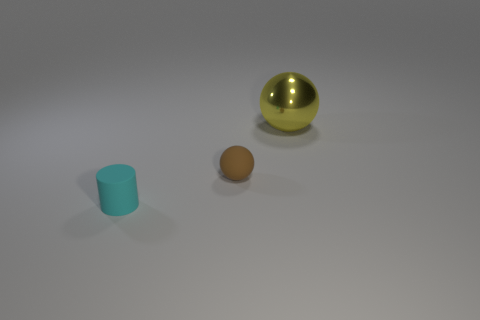Add 1 spheres. How many objects exist? 4 Subtract 1 yellow spheres. How many objects are left? 2 Subtract all balls. How many objects are left? 1 Subtract all gray cylinders. Subtract all brown spheres. How many cylinders are left? 1 Subtract all purple cylinders. How many green balls are left? 0 Subtract all big purple cubes. Subtract all tiny brown spheres. How many objects are left? 2 Add 1 small things. How many small things are left? 3 Add 1 gray metallic objects. How many gray metallic objects exist? 1 